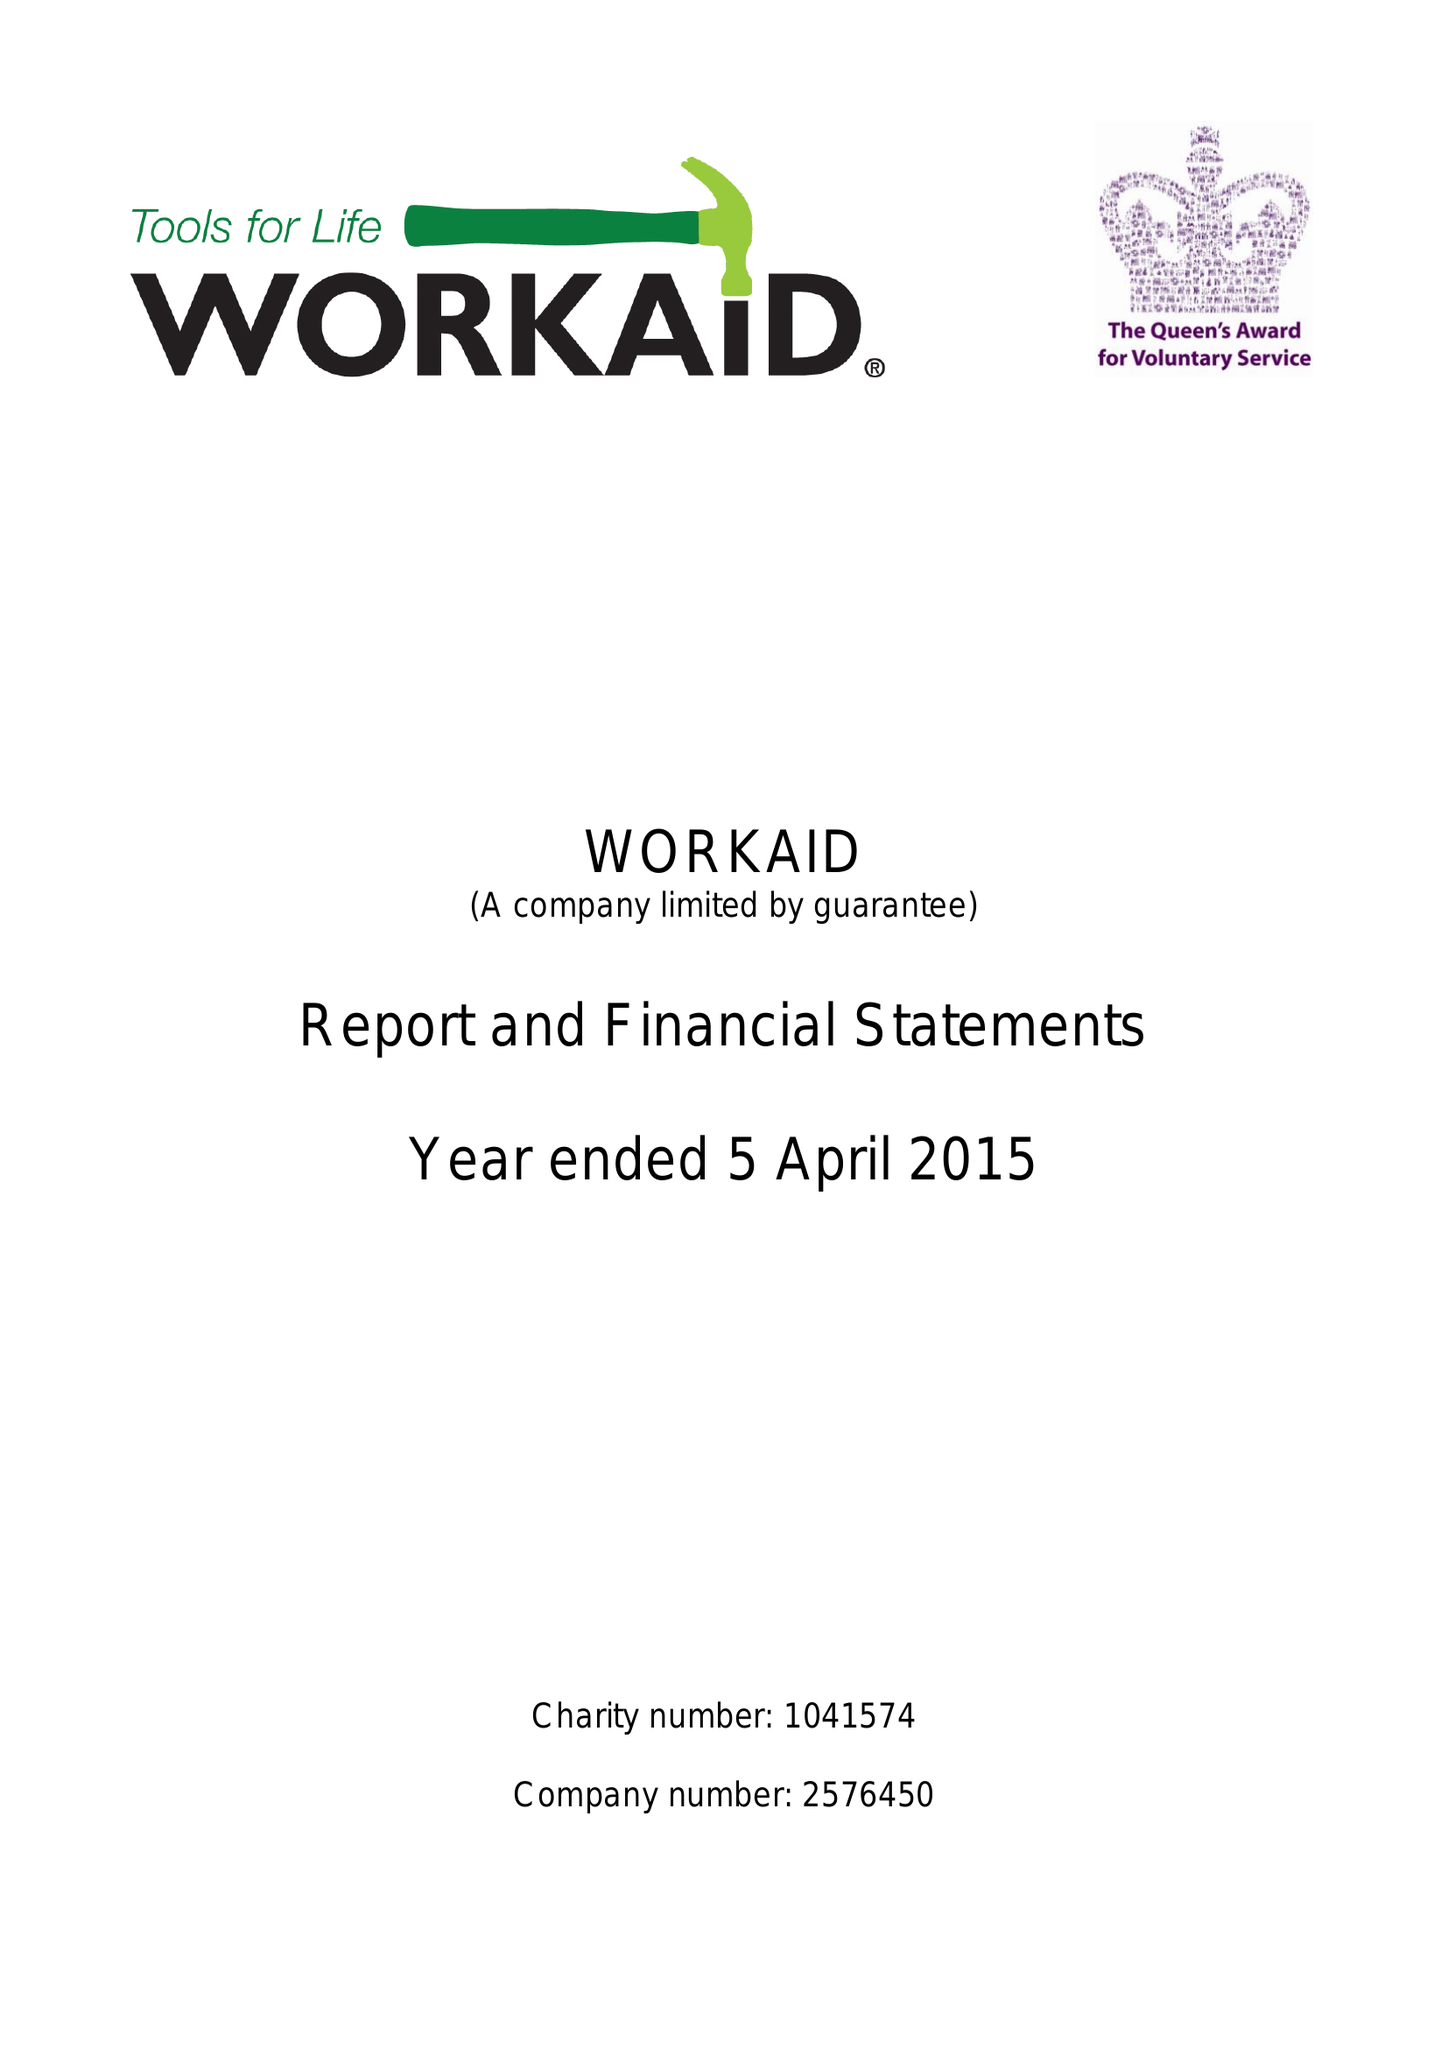What is the value for the income_annually_in_british_pounds?
Answer the question using a single word or phrase. 268130.00 